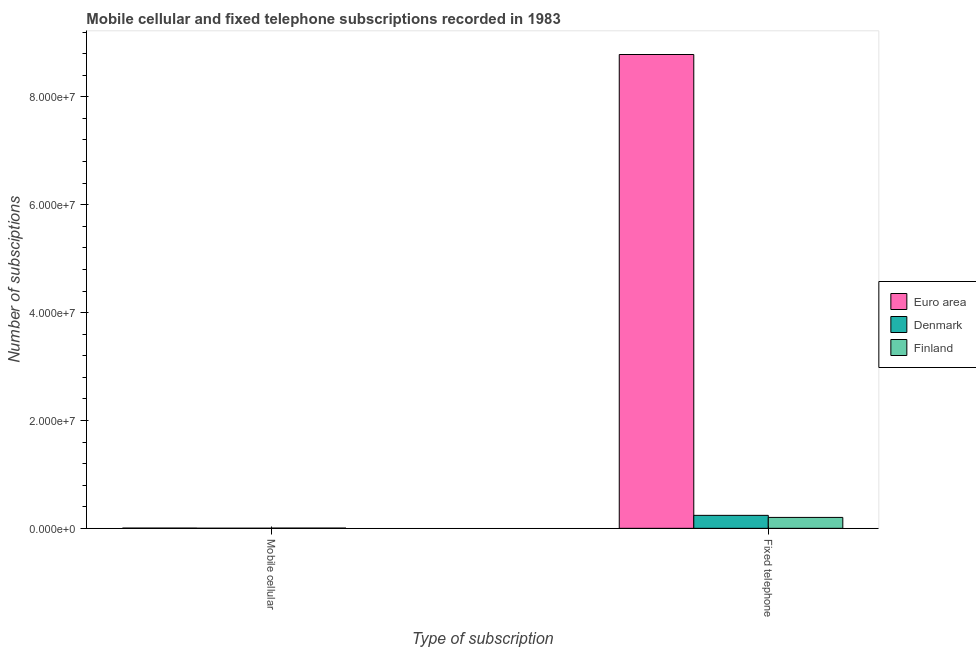Are the number of bars on each tick of the X-axis equal?
Offer a terse response. Yes. How many bars are there on the 1st tick from the left?
Your answer should be very brief. 3. What is the label of the 2nd group of bars from the left?
Make the answer very short. Fixed telephone. What is the number of mobile cellular subscriptions in Denmark?
Give a very brief answer. 1.61e+04. Across all countries, what is the maximum number of mobile cellular subscriptions?
Provide a short and direct response. 4.22e+04. Across all countries, what is the minimum number of fixed telephone subscriptions?
Your answer should be compact. 2.02e+06. In which country was the number of fixed telephone subscriptions minimum?
Give a very brief answer. Finland. What is the total number of mobile cellular subscriptions in the graph?
Your answer should be very brief. 1.01e+05. What is the difference between the number of mobile cellular subscriptions in Denmark and that in Finland?
Ensure brevity in your answer.  -2.61e+04. What is the difference between the number of fixed telephone subscriptions in Finland and the number of mobile cellular subscriptions in Euro area?
Make the answer very short. 1.98e+06. What is the average number of fixed telephone subscriptions per country?
Provide a succinct answer. 3.08e+07. What is the difference between the number of mobile cellular subscriptions and number of fixed telephone subscriptions in Euro area?
Your answer should be compact. -8.78e+07. Is the number of fixed telephone subscriptions in Finland less than that in Denmark?
Provide a succinct answer. Yes. In how many countries, is the number of fixed telephone subscriptions greater than the average number of fixed telephone subscriptions taken over all countries?
Offer a very short reply. 1. What does the 2nd bar from the right in Fixed telephone represents?
Ensure brevity in your answer.  Denmark. Are all the bars in the graph horizontal?
Provide a succinct answer. No. How many countries are there in the graph?
Provide a short and direct response. 3. What is the difference between two consecutive major ticks on the Y-axis?
Ensure brevity in your answer.  2.00e+07. Where does the legend appear in the graph?
Provide a short and direct response. Center right. How many legend labels are there?
Your answer should be very brief. 3. How are the legend labels stacked?
Offer a very short reply. Vertical. What is the title of the graph?
Offer a very short reply. Mobile cellular and fixed telephone subscriptions recorded in 1983. Does "Serbia" appear as one of the legend labels in the graph?
Your answer should be compact. No. What is the label or title of the X-axis?
Your answer should be compact. Type of subscription. What is the label or title of the Y-axis?
Keep it short and to the point. Number of subsciptions. What is the Number of subsciptions of Euro area in Mobile cellular?
Provide a succinct answer. 4.22e+04. What is the Number of subsciptions in Denmark in Mobile cellular?
Ensure brevity in your answer.  1.61e+04. What is the Number of subsciptions of Finland in Mobile cellular?
Offer a very short reply. 4.22e+04. What is the Number of subsciptions in Euro area in Fixed telephone?
Your answer should be compact. 8.78e+07. What is the Number of subsciptions of Denmark in Fixed telephone?
Offer a terse response. 2.40e+06. What is the Number of subsciptions of Finland in Fixed telephone?
Your answer should be very brief. 2.02e+06. Across all Type of subscription, what is the maximum Number of subsciptions in Euro area?
Offer a terse response. 8.78e+07. Across all Type of subscription, what is the maximum Number of subsciptions in Denmark?
Your response must be concise. 2.40e+06. Across all Type of subscription, what is the maximum Number of subsciptions of Finland?
Provide a succinct answer. 2.02e+06. Across all Type of subscription, what is the minimum Number of subsciptions in Euro area?
Offer a very short reply. 4.22e+04. Across all Type of subscription, what is the minimum Number of subsciptions of Denmark?
Provide a succinct answer. 1.61e+04. Across all Type of subscription, what is the minimum Number of subsciptions of Finland?
Your answer should be very brief. 4.22e+04. What is the total Number of subsciptions of Euro area in the graph?
Give a very brief answer. 8.79e+07. What is the total Number of subsciptions of Denmark in the graph?
Your answer should be very brief. 2.42e+06. What is the total Number of subsciptions in Finland in the graph?
Ensure brevity in your answer.  2.06e+06. What is the difference between the Number of subsciptions of Euro area in Mobile cellular and that in Fixed telephone?
Make the answer very short. -8.78e+07. What is the difference between the Number of subsciptions of Denmark in Mobile cellular and that in Fixed telephone?
Give a very brief answer. -2.39e+06. What is the difference between the Number of subsciptions of Finland in Mobile cellular and that in Fixed telephone?
Make the answer very short. -1.98e+06. What is the difference between the Number of subsciptions in Euro area in Mobile cellular and the Number of subsciptions in Denmark in Fixed telephone?
Your answer should be very brief. -2.36e+06. What is the difference between the Number of subsciptions of Euro area in Mobile cellular and the Number of subsciptions of Finland in Fixed telephone?
Keep it short and to the point. -1.98e+06. What is the difference between the Number of subsciptions in Denmark in Mobile cellular and the Number of subsciptions in Finland in Fixed telephone?
Your response must be concise. -2.00e+06. What is the average Number of subsciptions in Euro area per Type of subscription?
Offer a terse response. 4.39e+07. What is the average Number of subsciptions in Denmark per Type of subscription?
Provide a short and direct response. 1.21e+06. What is the average Number of subsciptions of Finland per Type of subscription?
Provide a short and direct response. 1.03e+06. What is the difference between the Number of subsciptions in Euro area and Number of subsciptions in Denmark in Mobile cellular?
Provide a succinct answer. 2.61e+04. What is the difference between the Number of subsciptions in Denmark and Number of subsciptions in Finland in Mobile cellular?
Make the answer very short. -2.61e+04. What is the difference between the Number of subsciptions in Euro area and Number of subsciptions in Denmark in Fixed telephone?
Provide a short and direct response. 8.54e+07. What is the difference between the Number of subsciptions in Euro area and Number of subsciptions in Finland in Fixed telephone?
Your response must be concise. 8.58e+07. What is the difference between the Number of subsciptions in Denmark and Number of subsciptions in Finland in Fixed telephone?
Offer a very short reply. 3.82e+05. What is the ratio of the Number of subsciptions in Euro area in Mobile cellular to that in Fixed telephone?
Offer a very short reply. 0. What is the ratio of the Number of subsciptions in Denmark in Mobile cellular to that in Fixed telephone?
Your answer should be compact. 0.01. What is the ratio of the Number of subsciptions of Finland in Mobile cellular to that in Fixed telephone?
Offer a very short reply. 0.02. What is the difference between the highest and the second highest Number of subsciptions in Euro area?
Your answer should be very brief. 8.78e+07. What is the difference between the highest and the second highest Number of subsciptions of Denmark?
Give a very brief answer. 2.39e+06. What is the difference between the highest and the second highest Number of subsciptions in Finland?
Your answer should be compact. 1.98e+06. What is the difference between the highest and the lowest Number of subsciptions of Euro area?
Give a very brief answer. 8.78e+07. What is the difference between the highest and the lowest Number of subsciptions in Denmark?
Make the answer very short. 2.39e+06. What is the difference between the highest and the lowest Number of subsciptions of Finland?
Make the answer very short. 1.98e+06. 